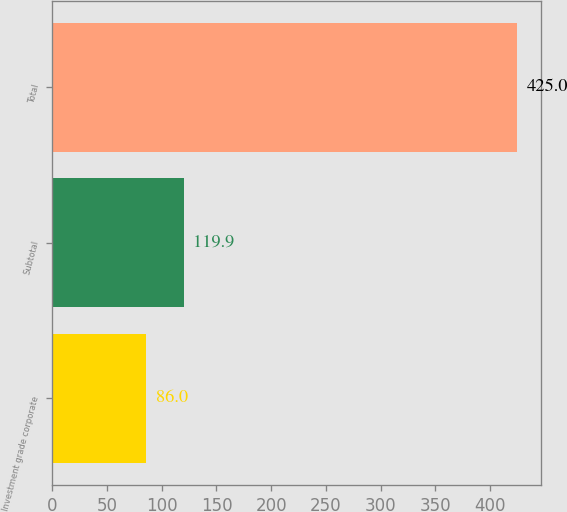<chart> <loc_0><loc_0><loc_500><loc_500><bar_chart><fcel>Investment grade corporate<fcel>Subtotal<fcel>Total<nl><fcel>86<fcel>119.9<fcel>425<nl></chart> 